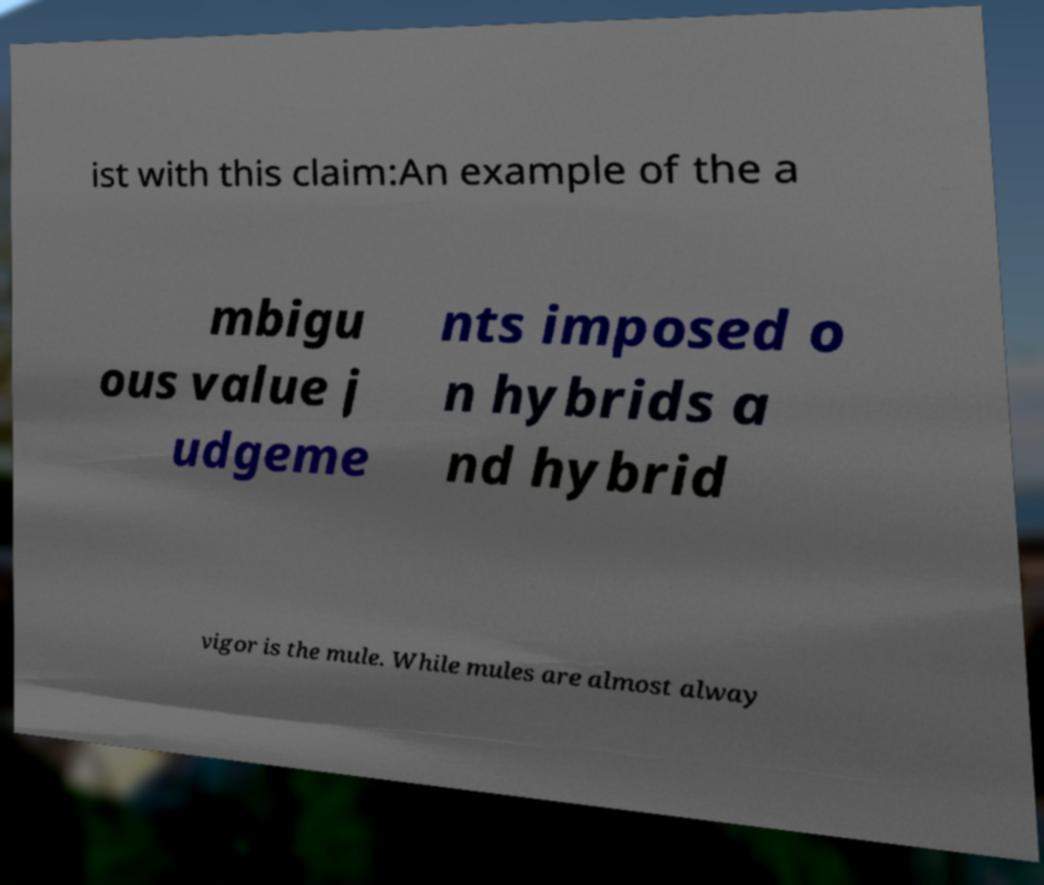Could you assist in decoding the text presented in this image and type it out clearly? ist with this claim:An example of the a mbigu ous value j udgeme nts imposed o n hybrids a nd hybrid vigor is the mule. While mules are almost alway 